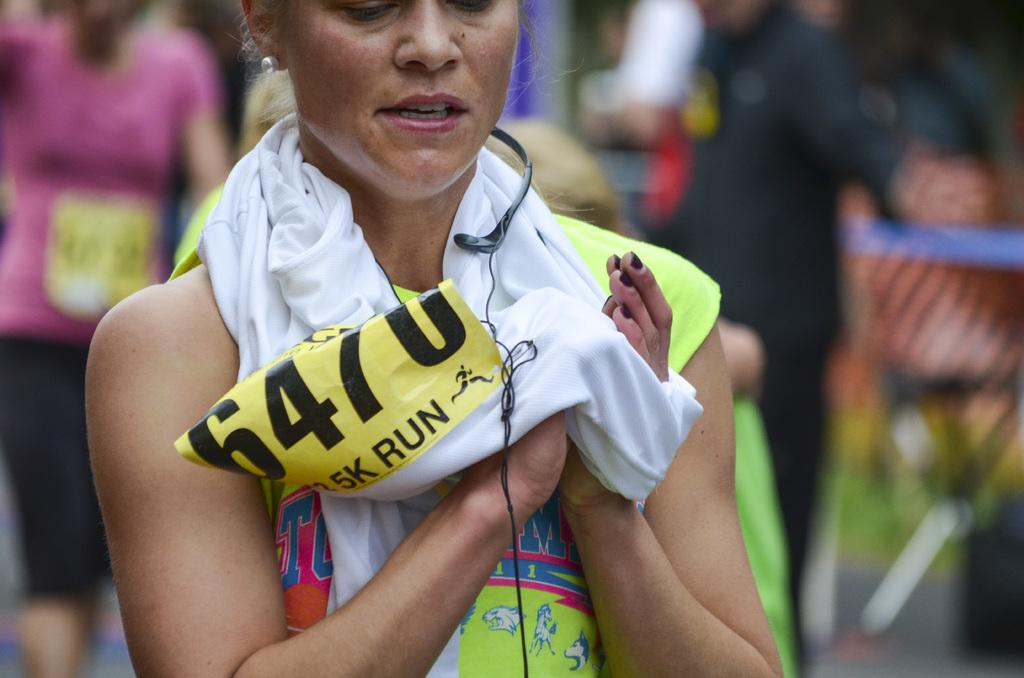<image>
Provide a brief description of the given image. Woman with a yellow sign and black letters which say 6470. 